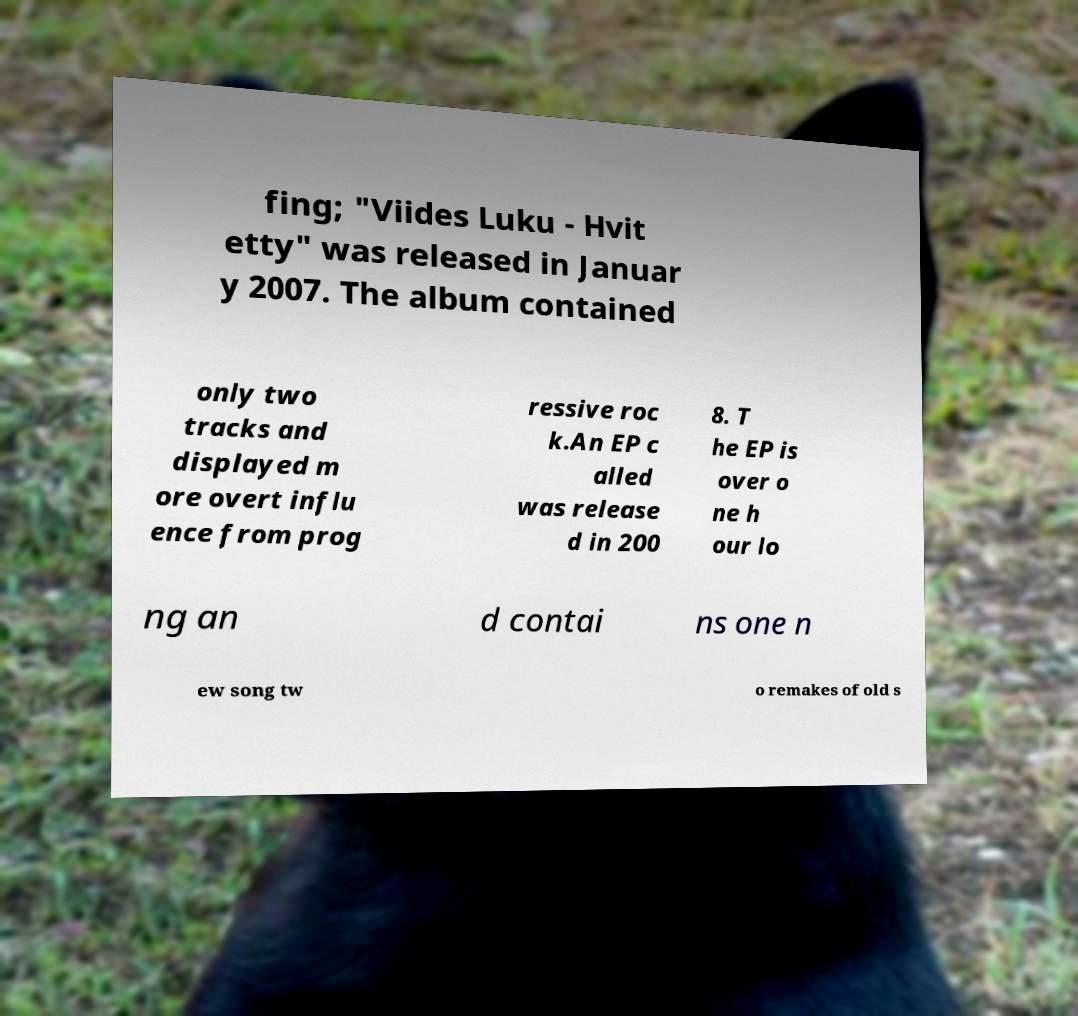What messages or text are displayed in this image? I need them in a readable, typed format. fing; "Viides Luku - Hvit etty" was released in Januar y 2007. The album contained only two tracks and displayed m ore overt influ ence from prog ressive roc k.An EP c alled was release d in 200 8. T he EP is over o ne h our lo ng an d contai ns one n ew song tw o remakes of old s 